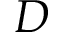Convert formula to latex. <formula><loc_0><loc_0><loc_500><loc_500>D</formula> 